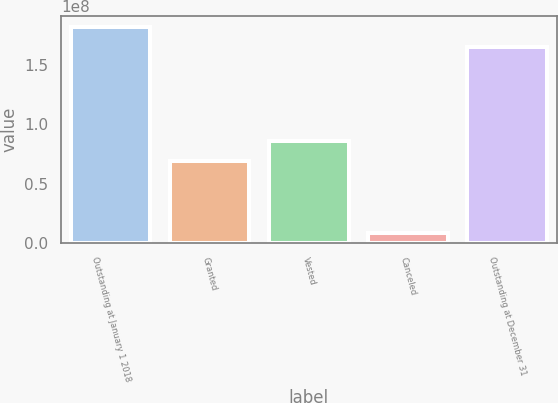<chart> <loc_0><loc_0><loc_500><loc_500><bar_chart><fcel>Outstanding at January 1 2018<fcel>Granted<fcel>Vested<fcel>Canceled<fcel>Outstanding at December 31<nl><fcel>1.82729e+08<fcel>6.88996e+07<fcel>8.60076e+07<fcel>8.194e+06<fcel>1.65621e+08<nl></chart> 